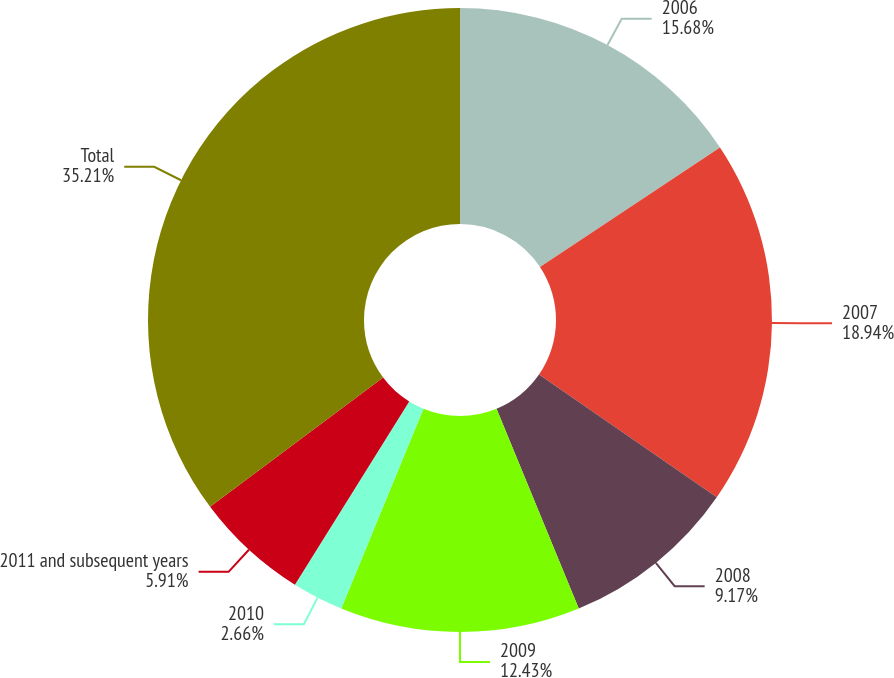Convert chart to OTSL. <chart><loc_0><loc_0><loc_500><loc_500><pie_chart><fcel>2006<fcel>2007<fcel>2008<fcel>2009<fcel>2010<fcel>2011 and subsequent years<fcel>Total<nl><fcel>15.68%<fcel>18.94%<fcel>9.17%<fcel>12.43%<fcel>2.66%<fcel>5.91%<fcel>35.22%<nl></chart> 